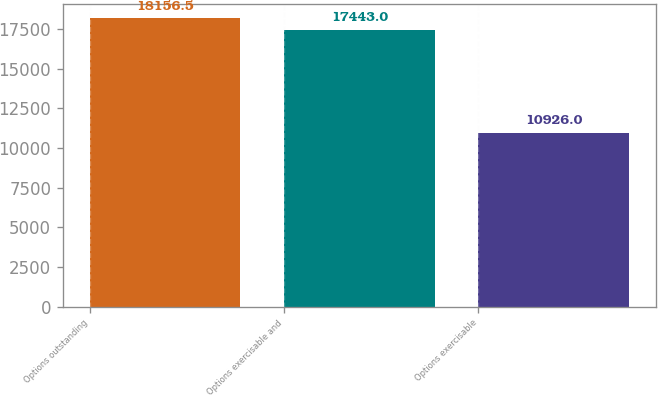Convert chart. <chart><loc_0><loc_0><loc_500><loc_500><bar_chart><fcel>Options outstanding<fcel>Options exercisable and<fcel>Options exercisable<nl><fcel>18156.5<fcel>17443<fcel>10926<nl></chart> 